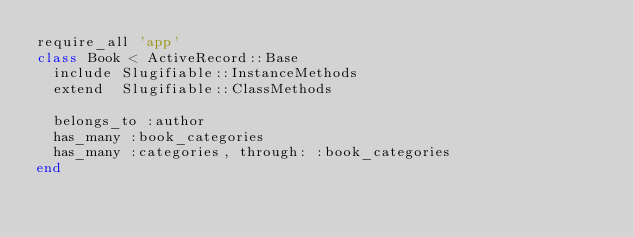Convert code to text. <code><loc_0><loc_0><loc_500><loc_500><_Ruby_>require_all 'app'
class Book < ActiveRecord::Base
  include Slugifiable::InstanceMethods
  extend  Slugifiable::ClassMethods

  belongs_to :author
  has_many :book_categories
  has_many :categories, through: :book_categories
end
</code> 